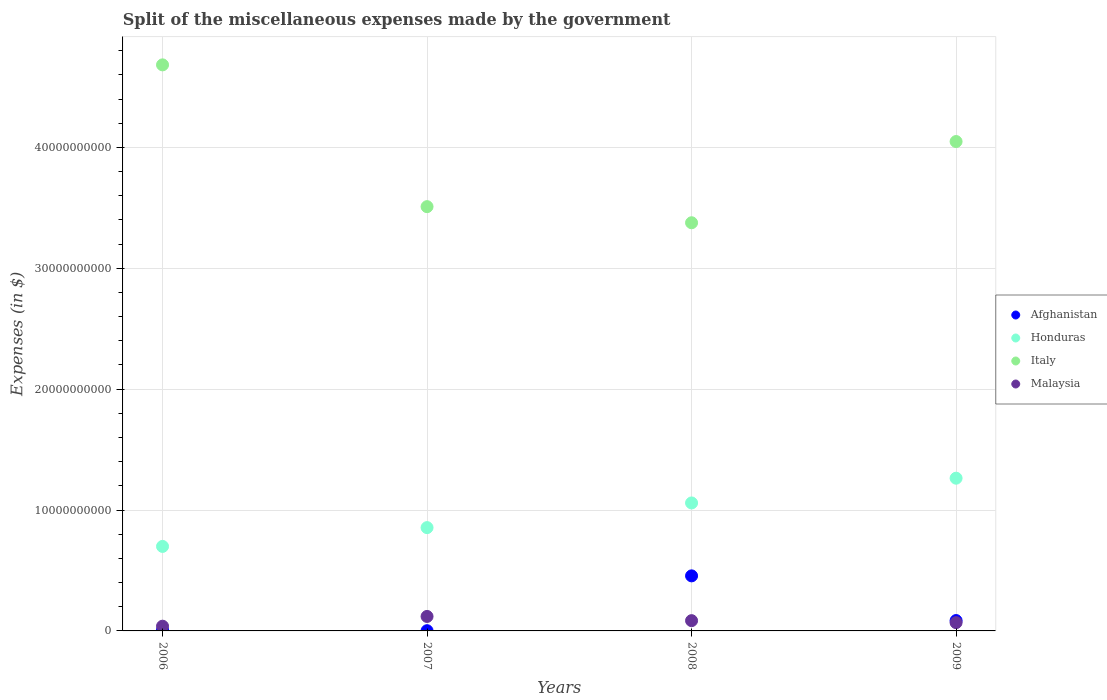Is the number of dotlines equal to the number of legend labels?
Provide a succinct answer. Yes. What is the miscellaneous expenses made by the government in Afghanistan in 2009?
Provide a short and direct response. 8.57e+08. Across all years, what is the maximum miscellaneous expenses made by the government in Malaysia?
Offer a terse response. 1.20e+09. Across all years, what is the minimum miscellaneous expenses made by the government in Italy?
Keep it short and to the point. 3.38e+1. In which year was the miscellaneous expenses made by the government in Afghanistan maximum?
Your answer should be compact. 2008. What is the total miscellaneous expenses made by the government in Italy in the graph?
Provide a short and direct response. 1.56e+11. What is the difference between the miscellaneous expenses made by the government in Malaysia in 2007 and that in 2008?
Offer a very short reply. 3.48e+08. What is the difference between the miscellaneous expenses made by the government in Honduras in 2007 and the miscellaneous expenses made by the government in Italy in 2009?
Offer a very short reply. -3.19e+1. What is the average miscellaneous expenses made by the government in Afghanistan per year?
Your response must be concise. 1.37e+09. In the year 2008, what is the difference between the miscellaneous expenses made by the government in Afghanistan and miscellaneous expenses made by the government in Malaysia?
Your answer should be compact. 3.71e+09. What is the ratio of the miscellaneous expenses made by the government in Afghanistan in 2007 to that in 2009?
Your response must be concise. 0.02. Is the miscellaneous expenses made by the government in Afghanistan in 2008 less than that in 2009?
Make the answer very short. No. Is the difference between the miscellaneous expenses made by the government in Afghanistan in 2007 and 2008 greater than the difference between the miscellaneous expenses made by the government in Malaysia in 2007 and 2008?
Provide a succinct answer. No. What is the difference between the highest and the second highest miscellaneous expenses made by the government in Malaysia?
Ensure brevity in your answer.  3.48e+08. What is the difference between the highest and the lowest miscellaneous expenses made by the government in Malaysia?
Keep it short and to the point. 8.07e+08. In how many years, is the miscellaneous expenses made by the government in Honduras greater than the average miscellaneous expenses made by the government in Honduras taken over all years?
Give a very brief answer. 2. Is it the case that in every year, the sum of the miscellaneous expenses made by the government in Malaysia and miscellaneous expenses made by the government in Afghanistan  is greater than the miscellaneous expenses made by the government in Honduras?
Your answer should be very brief. No. Does the miscellaneous expenses made by the government in Malaysia monotonically increase over the years?
Keep it short and to the point. No. Is the miscellaneous expenses made by the government in Afghanistan strictly greater than the miscellaneous expenses made by the government in Honduras over the years?
Give a very brief answer. No. How many dotlines are there?
Your response must be concise. 4. How many years are there in the graph?
Provide a short and direct response. 4. What is the difference between two consecutive major ticks on the Y-axis?
Offer a terse response. 1.00e+1. Are the values on the major ticks of Y-axis written in scientific E-notation?
Give a very brief answer. No. Does the graph contain any zero values?
Your answer should be compact. No. Where does the legend appear in the graph?
Give a very brief answer. Center right. How many legend labels are there?
Provide a short and direct response. 4. How are the legend labels stacked?
Provide a succinct answer. Vertical. What is the title of the graph?
Keep it short and to the point. Split of the miscellaneous expenses made by the government. What is the label or title of the X-axis?
Ensure brevity in your answer.  Years. What is the label or title of the Y-axis?
Ensure brevity in your answer.  Expenses (in $). What is the Expenses (in $) of Afghanistan in 2006?
Give a very brief answer. 6.85e+07. What is the Expenses (in $) of Honduras in 2006?
Your answer should be compact. 6.99e+09. What is the Expenses (in $) of Italy in 2006?
Give a very brief answer. 4.68e+1. What is the Expenses (in $) of Malaysia in 2006?
Provide a succinct answer. 3.91e+08. What is the Expenses (in $) of Afghanistan in 2007?
Provide a succinct answer. 1.89e+07. What is the Expenses (in $) in Honduras in 2007?
Make the answer very short. 8.55e+09. What is the Expenses (in $) of Italy in 2007?
Your response must be concise. 3.51e+1. What is the Expenses (in $) of Malaysia in 2007?
Ensure brevity in your answer.  1.20e+09. What is the Expenses (in $) of Afghanistan in 2008?
Ensure brevity in your answer.  4.55e+09. What is the Expenses (in $) of Honduras in 2008?
Keep it short and to the point. 1.06e+1. What is the Expenses (in $) in Italy in 2008?
Ensure brevity in your answer.  3.38e+1. What is the Expenses (in $) in Malaysia in 2008?
Provide a succinct answer. 8.49e+08. What is the Expenses (in $) of Afghanistan in 2009?
Give a very brief answer. 8.57e+08. What is the Expenses (in $) in Honduras in 2009?
Offer a very short reply. 1.26e+1. What is the Expenses (in $) in Italy in 2009?
Provide a short and direct response. 4.05e+1. What is the Expenses (in $) of Malaysia in 2009?
Offer a terse response. 6.85e+08. Across all years, what is the maximum Expenses (in $) of Afghanistan?
Offer a terse response. 4.55e+09. Across all years, what is the maximum Expenses (in $) of Honduras?
Keep it short and to the point. 1.26e+1. Across all years, what is the maximum Expenses (in $) in Italy?
Your response must be concise. 4.68e+1. Across all years, what is the maximum Expenses (in $) of Malaysia?
Provide a short and direct response. 1.20e+09. Across all years, what is the minimum Expenses (in $) in Afghanistan?
Your response must be concise. 1.89e+07. Across all years, what is the minimum Expenses (in $) of Honduras?
Your answer should be very brief. 6.99e+09. Across all years, what is the minimum Expenses (in $) of Italy?
Give a very brief answer. 3.38e+1. Across all years, what is the minimum Expenses (in $) of Malaysia?
Ensure brevity in your answer.  3.91e+08. What is the total Expenses (in $) of Afghanistan in the graph?
Provide a succinct answer. 5.50e+09. What is the total Expenses (in $) in Honduras in the graph?
Make the answer very short. 3.88e+1. What is the total Expenses (in $) of Italy in the graph?
Keep it short and to the point. 1.56e+11. What is the total Expenses (in $) in Malaysia in the graph?
Offer a very short reply. 3.12e+09. What is the difference between the Expenses (in $) of Afghanistan in 2006 and that in 2007?
Your answer should be compact. 4.96e+07. What is the difference between the Expenses (in $) in Honduras in 2006 and that in 2007?
Your answer should be very brief. -1.56e+09. What is the difference between the Expenses (in $) in Italy in 2006 and that in 2007?
Provide a short and direct response. 1.17e+1. What is the difference between the Expenses (in $) of Malaysia in 2006 and that in 2007?
Keep it short and to the point. -8.07e+08. What is the difference between the Expenses (in $) in Afghanistan in 2006 and that in 2008?
Provide a succinct answer. -4.49e+09. What is the difference between the Expenses (in $) in Honduras in 2006 and that in 2008?
Provide a short and direct response. -3.60e+09. What is the difference between the Expenses (in $) of Italy in 2006 and that in 2008?
Your response must be concise. 1.31e+1. What is the difference between the Expenses (in $) of Malaysia in 2006 and that in 2008?
Offer a terse response. -4.58e+08. What is the difference between the Expenses (in $) of Afghanistan in 2006 and that in 2009?
Your answer should be compact. -7.89e+08. What is the difference between the Expenses (in $) of Honduras in 2006 and that in 2009?
Your response must be concise. -5.64e+09. What is the difference between the Expenses (in $) in Italy in 2006 and that in 2009?
Keep it short and to the point. 6.34e+09. What is the difference between the Expenses (in $) of Malaysia in 2006 and that in 2009?
Your answer should be very brief. -2.94e+08. What is the difference between the Expenses (in $) in Afghanistan in 2007 and that in 2008?
Ensure brevity in your answer.  -4.54e+09. What is the difference between the Expenses (in $) in Honduras in 2007 and that in 2008?
Provide a succinct answer. -2.04e+09. What is the difference between the Expenses (in $) of Italy in 2007 and that in 2008?
Your answer should be very brief. 1.33e+09. What is the difference between the Expenses (in $) of Malaysia in 2007 and that in 2008?
Your answer should be very brief. 3.48e+08. What is the difference between the Expenses (in $) of Afghanistan in 2007 and that in 2009?
Your answer should be very brief. -8.38e+08. What is the difference between the Expenses (in $) in Honduras in 2007 and that in 2009?
Ensure brevity in your answer.  -4.09e+09. What is the difference between the Expenses (in $) of Italy in 2007 and that in 2009?
Give a very brief answer. -5.39e+09. What is the difference between the Expenses (in $) in Malaysia in 2007 and that in 2009?
Your answer should be compact. 5.12e+08. What is the difference between the Expenses (in $) of Afghanistan in 2008 and that in 2009?
Offer a terse response. 3.70e+09. What is the difference between the Expenses (in $) of Honduras in 2008 and that in 2009?
Your response must be concise. -2.05e+09. What is the difference between the Expenses (in $) in Italy in 2008 and that in 2009?
Provide a short and direct response. -6.72e+09. What is the difference between the Expenses (in $) in Malaysia in 2008 and that in 2009?
Your answer should be compact. 1.64e+08. What is the difference between the Expenses (in $) in Afghanistan in 2006 and the Expenses (in $) in Honduras in 2007?
Provide a short and direct response. -8.48e+09. What is the difference between the Expenses (in $) of Afghanistan in 2006 and the Expenses (in $) of Italy in 2007?
Ensure brevity in your answer.  -3.50e+1. What is the difference between the Expenses (in $) of Afghanistan in 2006 and the Expenses (in $) of Malaysia in 2007?
Your answer should be compact. -1.13e+09. What is the difference between the Expenses (in $) of Honduras in 2006 and the Expenses (in $) of Italy in 2007?
Give a very brief answer. -2.81e+1. What is the difference between the Expenses (in $) in Honduras in 2006 and the Expenses (in $) in Malaysia in 2007?
Offer a very short reply. 5.79e+09. What is the difference between the Expenses (in $) in Italy in 2006 and the Expenses (in $) in Malaysia in 2007?
Ensure brevity in your answer.  4.56e+1. What is the difference between the Expenses (in $) in Afghanistan in 2006 and the Expenses (in $) in Honduras in 2008?
Your response must be concise. -1.05e+1. What is the difference between the Expenses (in $) of Afghanistan in 2006 and the Expenses (in $) of Italy in 2008?
Give a very brief answer. -3.37e+1. What is the difference between the Expenses (in $) of Afghanistan in 2006 and the Expenses (in $) of Malaysia in 2008?
Your response must be concise. -7.81e+08. What is the difference between the Expenses (in $) of Honduras in 2006 and the Expenses (in $) of Italy in 2008?
Keep it short and to the point. -2.68e+1. What is the difference between the Expenses (in $) of Honduras in 2006 and the Expenses (in $) of Malaysia in 2008?
Ensure brevity in your answer.  6.14e+09. What is the difference between the Expenses (in $) of Italy in 2006 and the Expenses (in $) of Malaysia in 2008?
Your answer should be very brief. 4.60e+1. What is the difference between the Expenses (in $) of Afghanistan in 2006 and the Expenses (in $) of Honduras in 2009?
Your answer should be very brief. -1.26e+1. What is the difference between the Expenses (in $) of Afghanistan in 2006 and the Expenses (in $) of Italy in 2009?
Make the answer very short. -4.04e+1. What is the difference between the Expenses (in $) in Afghanistan in 2006 and the Expenses (in $) in Malaysia in 2009?
Provide a short and direct response. -6.16e+08. What is the difference between the Expenses (in $) of Honduras in 2006 and the Expenses (in $) of Italy in 2009?
Your answer should be compact. -3.35e+1. What is the difference between the Expenses (in $) of Honduras in 2006 and the Expenses (in $) of Malaysia in 2009?
Your answer should be compact. 6.31e+09. What is the difference between the Expenses (in $) of Italy in 2006 and the Expenses (in $) of Malaysia in 2009?
Keep it short and to the point. 4.61e+1. What is the difference between the Expenses (in $) in Afghanistan in 2007 and the Expenses (in $) in Honduras in 2008?
Keep it short and to the point. -1.06e+1. What is the difference between the Expenses (in $) in Afghanistan in 2007 and the Expenses (in $) in Italy in 2008?
Your answer should be very brief. -3.37e+1. What is the difference between the Expenses (in $) in Afghanistan in 2007 and the Expenses (in $) in Malaysia in 2008?
Offer a terse response. -8.30e+08. What is the difference between the Expenses (in $) in Honduras in 2007 and the Expenses (in $) in Italy in 2008?
Make the answer very short. -2.52e+1. What is the difference between the Expenses (in $) of Honduras in 2007 and the Expenses (in $) of Malaysia in 2008?
Your answer should be very brief. 7.70e+09. What is the difference between the Expenses (in $) of Italy in 2007 and the Expenses (in $) of Malaysia in 2008?
Make the answer very short. 3.42e+1. What is the difference between the Expenses (in $) in Afghanistan in 2007 and the Expenses (in $) in Honduras in 2009?
Offer a terse response. -1.26e+1. What is the difference between the Expenses (in $) of Afghanistan in 2007 and the Expenses (in $) of Italy in 2009?
Your answer should be compact. -4.05e+1. What is the difference between the Expenses (in $) in Afghanistan in 2007 and the Expenses (in $) in Malaysia in 2009?
Provide a short and direct response. -6.66e+08. What is the difference between the Expenses (in $) of Honduras in 2007 and the Expenses (in $) of Italy in 2009?
Offer a very short reply. -3.19e+1. What is the difference between the Expenses (in $) of Honduras in 2007 and the Expenses (in $) of Malaysia in 2009?
Provide a succinct answer. 7.86e+09. What is the difference between the Expenses (in $) of Italy in 2007 and the Expenses (in $) of Malaysia in 2009?
Offer a terse response. 3.44e+1. What is the difference between the Expenses (in $) of Afghanistan in 2008 and the Expenses (in $) of Honduras in 2009?
Make the answer very short. -8.08e+09. What is the difference between the Expenses (in $) in Afghanistan in 2008 and the Expenses (in $) in Italy in 2009?
Your response must be concise. -3.59e+1. What is the difference between the Expenses (in $) in Afghanistan in 2008 and the Expenses (in $) in Malaysia in 2009?
Provide a succinct answer. 3.87e+09. What is the difference between the Expenses (in $) in Honduras in 2008 and the Expenses (in $) in Italy in 2009?
Your answer should be compact. -2.99e+1. What is the difference between the Expenses (in $) in Honduras in 2008 and the Expenses (in $) in Malaysia in 2009?
Keep it short and to the point. 9.90e+09. What is the difference between the Expenses (in $) of Italy in 2008 and the Expenses (in $) of Malaysia in 2009?
Your answer should be very brief. 3.31e+1. What is the average Expenses (in $) of Afghanistan per year?
Keep it short and to the point. 1.37e+09. What is the average Expenses (in $) of Honduras per year?
Offer a very short reply. 9.69e+09. What is the average Expenses (in $) in Italy per year?
Ensure brevity in your answer.  3.90e+1. What is the average Expenses (in $) of Malaysia per year?
Make the answer very short. 7.81e+08. In the year 2006, what is the difference between the Expenses (in $) in Afghanistan and Expenses (in $) in Honduras?
Your response must be concise. -6.92e+09. In the year 2006, what is the difference between the Expenses (in $) of Afghanistan and Expenses (in $) of Italy?
Provide a succinct answer. -4.68e+1. In the year 2006, what is the difference between the Expenses (in $) of Afghanistan and Expenses (in $) of Malaysia?
Offer a very short reply. -3.22e+08. In the year 2006, what is the difference between the Expenses (in $) in Honduras and Expenses (in $) in Italy?
Ensure brevity in your answer.  -3.98e+1. In the year 2006, what is the difference between the Expenses (in $) in Honduras and Expenses (in $) in Malaysia?
Provide a succinct answer. 6.60e+09. In the year 2006, what is the difference between the Expenses (in $) in Italy and Expenses (in $) in Malaysia?
Your answer should be very brief. 4.64e+1. In the year 2007, what is the difference between the Expenses (in $) in Afghanistan and Expenses (in $) in Honduras?
Keep it short and to the point. -8.53e+09. In the year 2007, what is the difference between the Expenses (in $) in Afghanistan and Expenses (in $) in Italy?
Your answer should be very brief. -3.51e+1. In the year 2007, what is the difference between the Expenses (in $) of Afghanistan and Expenses (in $) of Malaysia?
Offer a very short reply. -1.18e+09. In the year 2007, what is the difference between the Expenses (in $) of Honduras and Expenses (in $) of Italy?
Your answer should be compact. -2.66e+1. In the year 2007, what is the difference between the Expenses (in $) in Honduras and Expenses (in $) in Malaysia?
Provide a short and direct response. 7.35e+09. In the year 2007, what is the difference between the Expenses (in $) of Italy and Expenses (in $) of Malaysia?
Provide a succinct answer. 3.39e+1. In the year 2008, what is the difference between the Expenses (in $) of Afghanistan and Expenses (in $) of Honduras?
Offer a very short reply. -6.03e+09. In the year 2008, what is the difference between the Expenses (in $) of Afghanistan and Expenses (in $) of Italy?
Your response must be concise. -2.92e+1. In the year 2008, what is the difference between the Expenses (in $) in Afghanistan and Expenses (in $) in Malaysia?
Your response must be concise. 3.71e+09. In the year 2008, what is the difference between the Expenses (in $) in Honduras and Expenses (in $) in Italy?
Keep it short and to the point. -2.32e+1. In the year 2008, what is the difference between the Expenses (in $) of Honduras and Expenses (in $) of Malaysia?
Make the answer very short. 9.74e+09. In the year 2008, what is the difference between the Expenses (in $) of Italy and Expenses (in $) of Malaysia?
Keep it short and to the point. 3.29e+1. In the year 2009, what is the difference between the Expenses (in $) of Afghanistan and Expenses (in $) of Honduras?
Your answer should be compact. -1.18e+1. In the year 2009, what is the difference between the Expenses (in $) in Afghanistan and Expenses (in $) in Italy?
Make the answer very short. -3.96e+1. In the year 2009, what is the difference between the Expenses (in $) of Afghanistan and Expenses (in $) of Malaysia?
Provide a short and direct response. 1.72e+08. In the year 2009, what is the difference between the Expenses (in $) in Honduras and Expenses (in $) in Italy?
Keep it short and to the point. -2.78e+1. In the year 2009, what is the difference between the Expenses (in $) in Honduras and Expenses (in $) in Malaysia?
Ensure brevity in your answer.  1.19e+1. In the year 2009, what is the difference between the Expenses (in $) of Italy and Expenses (in $) of Malaysia?
Make the answer very short. 3.98e+1. What is the ratio of the Expenses (in $) of Afghanistan in 2006 to that in 2007?
Keep it short and to the point. 3.62. What is the ratio of the Expenses (in $) in Honduras in 2006 to that in 2007?
Provide a short and direct response. 0.82. What is the ratio of the Expenses (in $) in Italy in 2006 to that in 2007?
Provide a succinct answer. 1.33. What is the ratio of the Expenses (in $) in Malaysia in 2006 to that in 2007?
Give a very brief answer. 0.33. What is the ratio of the Expenses (in $) in Afghanistan in 2006 to that in 2008?
Ensure brevity in your answer.  0.01. What is the ratio of the Expenses (in $) of Honduras in 2006 to that in 2008?
Keep it short and to the point. 0.66. What is the ratio of the Expenses (in $) in Italy in 2006 to that in 2008?
Provide a succinct answer. 1.39. What is the ratio of the Expenses (in $) of Malaysia in 2006 to that in 2008?
Keep it short and to the point. 0.46. What is the ratio of the Expenses (in $) in Afghanistan in 2006 to that in 2009?
Offer a terse response. 0.08. What is the ratio of the Expenses (in $) of Honduras in 2006 to that in 2009?
Make the answer very short. 0.55. What is the ratio of the Expenses (in $) in Italy in 2006 to that in 2009?
Your answer should be compact. 1.16. What is the ratio of the Expenses (in $) in Malaysia in 2006 to that in 2009?
Provide a succinct answer. 0.57. What is the ratio of the Expenses (in $) in Afghanistan in 2007 to that in 2008?
Provide a succinct answer. 0. What is the ratio of the Expenses (in $) in Honduras in 2007 to that in 2008?
Offer a very short reply. 0.81. What is the ratio of the Expenses (in $) in Italy in 2007 to that in 2008?
Make the answer very short. 1.04. What is the ratio of the Expenses (in $) of Malaysia in 2007 to that in 2008?
Offer a terse response. 1.41. What is the ratio of the Expenses (in $) in Afghanistan in 2007 to that in 2009?
Offer a very short reply. 0.02. What is the ratio of the Expenses (in $) of Honduras in 2007 to that in 2009?
Offer a very short reply. 0.68. What is the ratio of the Expenses (in $) of Italy in 2007 to that in 2009?
Your answer should be compact. 0.87. What is the ratio of the Expenses (in $) in Malaysia in 2007 to that in 2009?
Give a very brief answer. 1.75. What is the ratio of the Expenses (in $) of Afghanistan in 2008 to that in 2009?
Provide a succinct answer. 5.31. What is the ratio of the Expenses (in $) in Honduras in 2008 to that in 2009?
Give a very brief answer. 0.84. What is the ratio of the Expenses (in $) in Italy in 2008 to that in 2009?
Offer a terse response. 0.83. What is the ratio of the Expenses (in $) of Malaysia in 2008 to that in 2009?
Your answer should be very brief. 1.24. What is the difference between the highest and the second highest Expenses (in $) in Afghanistan?
Provide a short and direct response. 3.70e+09. What is the difference between the highest and the second highest Expenses (in $) in Honduras?
Your answer should be compact. 2.05e+09. What is the difference between the highest and the second highest Expenses (in $) of Italy?
Keep it short and to the point. 6.34e+09. What is the difference between the highest and the second highest Expenses (in $) of Malaysia?
Offer a terse response. 3.48e+08. What is the difference between the highest and the lowest Expenses (in $) of Afghanistan?
Provide a short and direct response. 4.54e+09. What is the difference between the highest and the lowest Expenses (in $) in Honduras?
Provide a short and direct response. 5.64e+09. What is the difference between the highest and the lowest Expenses (in $) of Italy?
Offer a very short reply. 1.31e+1. What is the difference between the highest and the lowest Expenses (in $) in Malaysia?
Your answer should be compact. 8.07e+08. 